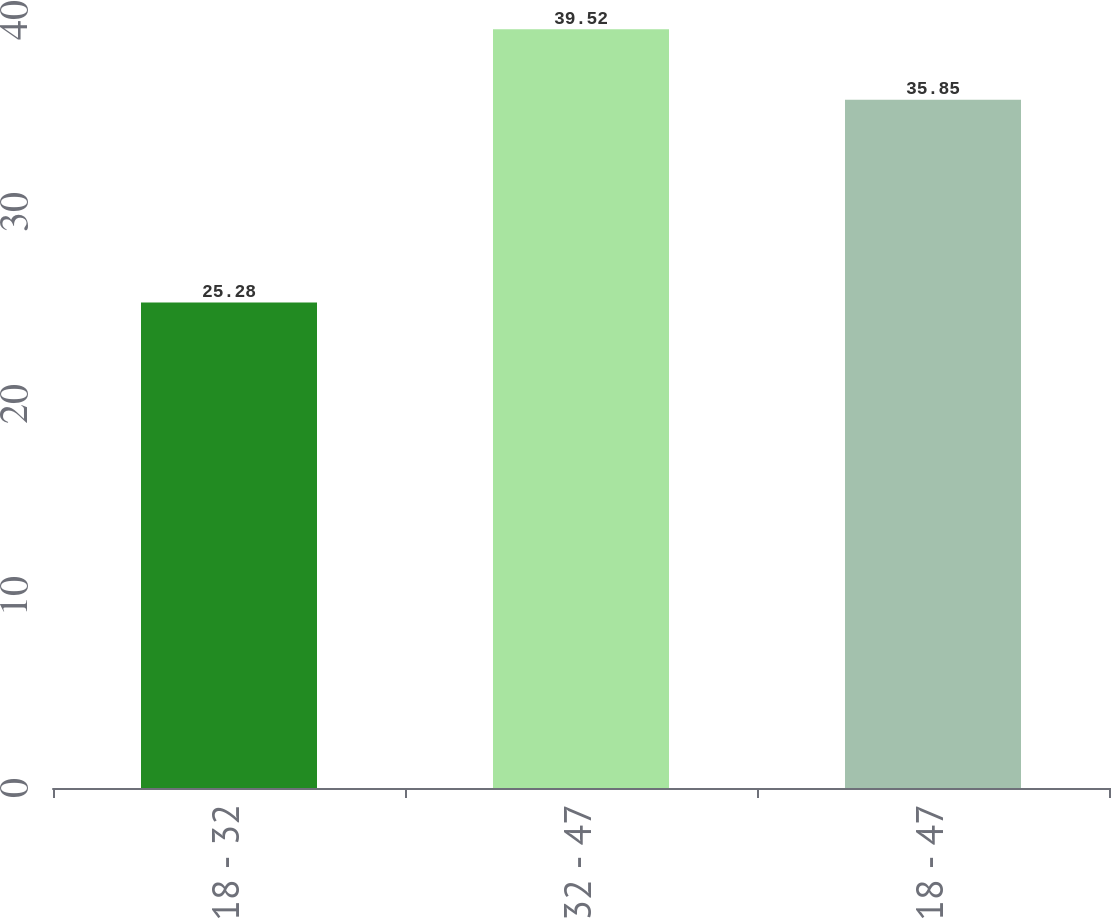Convert chart to OTSL. <chart><loc_0><loc_0><loc_500><loc_500><bar_chart><fcel>18 - 32<fcel>32 - 47<fcel>18 - 47<nl><fcel>25.28<fcel>39.52<fcel>35.85<nl></chart> 